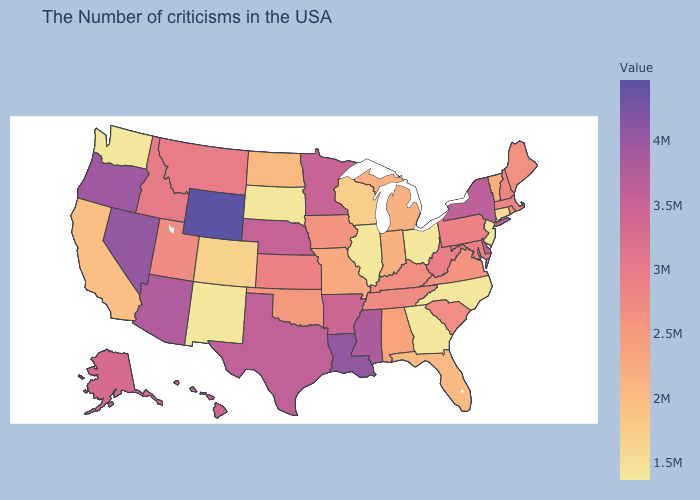Which states have the lowest value in the USA?
Quick response, please. New Jersey, North Carolina, Ohio, Georgia, Illinois, South Dakota, New Mexico, Washington. Among the states that border Rhode Island , which have the lowest value?
Concise answer only. Connecticut. Is the legend a continuous bar?
Give a very brief answer. Yes. Does Illinois have the highest value in the MidWest?
Keep it brief. No. 